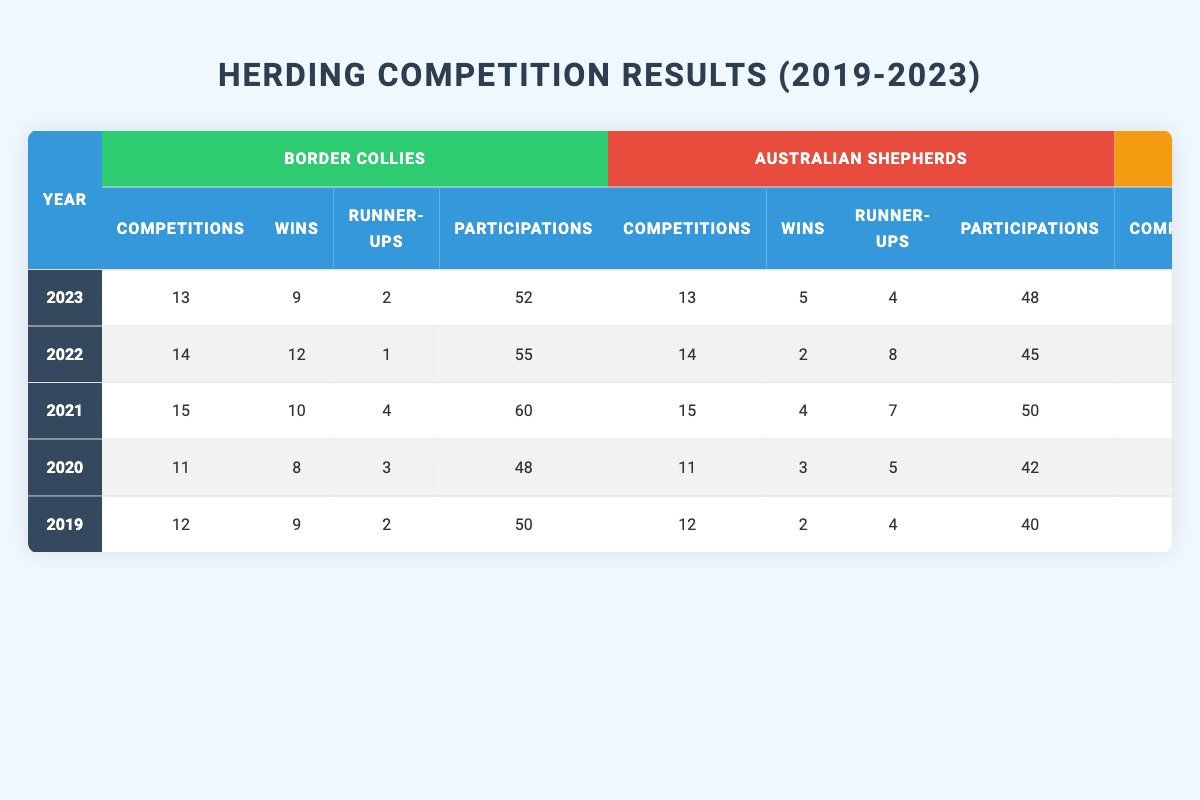What was the total number of wins for Australian Shepherds over the five years? To find the total wins for Australian Shepherds from 2019 to 2023, we sum their wins: 2 + 3 + 4 + 2 + 5 = 16.
Answer: 16 In which year did Australian Shepherds achieve their highest number of wins? By examining the wins from each year: 2019 (2), 2020 (3), 2021 (4), 2022 (2), and 2023 (5), we see that the highest number of wins (5) was in 2023.
Answer: 2023 How many competitions did Border Collies participate in during 2021? The table shows that Border Collies participated in 60 competitions in 2021.
Answer: 60 Which breed had the highest runner-up placements in 2020? In 2020, Border Collies had 3 runner-up placements, Australian Shepherds had 5, and Other Breeds had 2. Therefore, Australian Shepherds had the highest runner-ups.
Answer: Australian Shepherds What is the average number of participations for Other Breeds over the five years? To find the average participations, we sum the participations: 30 for 2019, 20 for 2020, 25 for 2021, 30 for 2022, and 25 for 2023. The total is 30 + 20 + 25 + 30 + 25 = 130, and dividing by 5 gives an average of 130 / 5 = 26.
Answer: 26 Did any breed reach zero wins in any year? Checking the data: Other Breeds had zero wins in 2020, 2022, and 2023. Therefore, the statement is true.
Answer: Yes Which breed had the most consistent number of wins across the years? By closely examining the wins: Border Collies had 9, 8, 10, 12, and 9; Australian Shepherds had 2, 3, 4, 2, and 5; and Other Breeds had 1, 0, 1, 0, and 0. Border Collies' wins were more stable compared to the others, showing less fluctuation.
Answer: Border Collies How many total competitions were held from 2019 to 2023? Adding all competitions: 12 + 11 + 15 + 14 + 13 = 65 competitions in total over the five years.
Answer: 65 What was the percentage of wins for Border Collies in 2022? In 2022, Border Collies had 12 wins out of 14 competitions. To calculate the percentage, (12 / 14) * 100 = 85.71%.
Answer: 85.71% Which breed showed the greatest improvement in wins from 2019 to 2023? Analyzing the wins: Border Collies went from 9 in 2019 to 9 in 2023 (no improvement), while Australian Shepherds increased from 2 in 2019 to 5 in 2023, showing a net improvement of 3 wins.
Answer: Australian Shepherds 